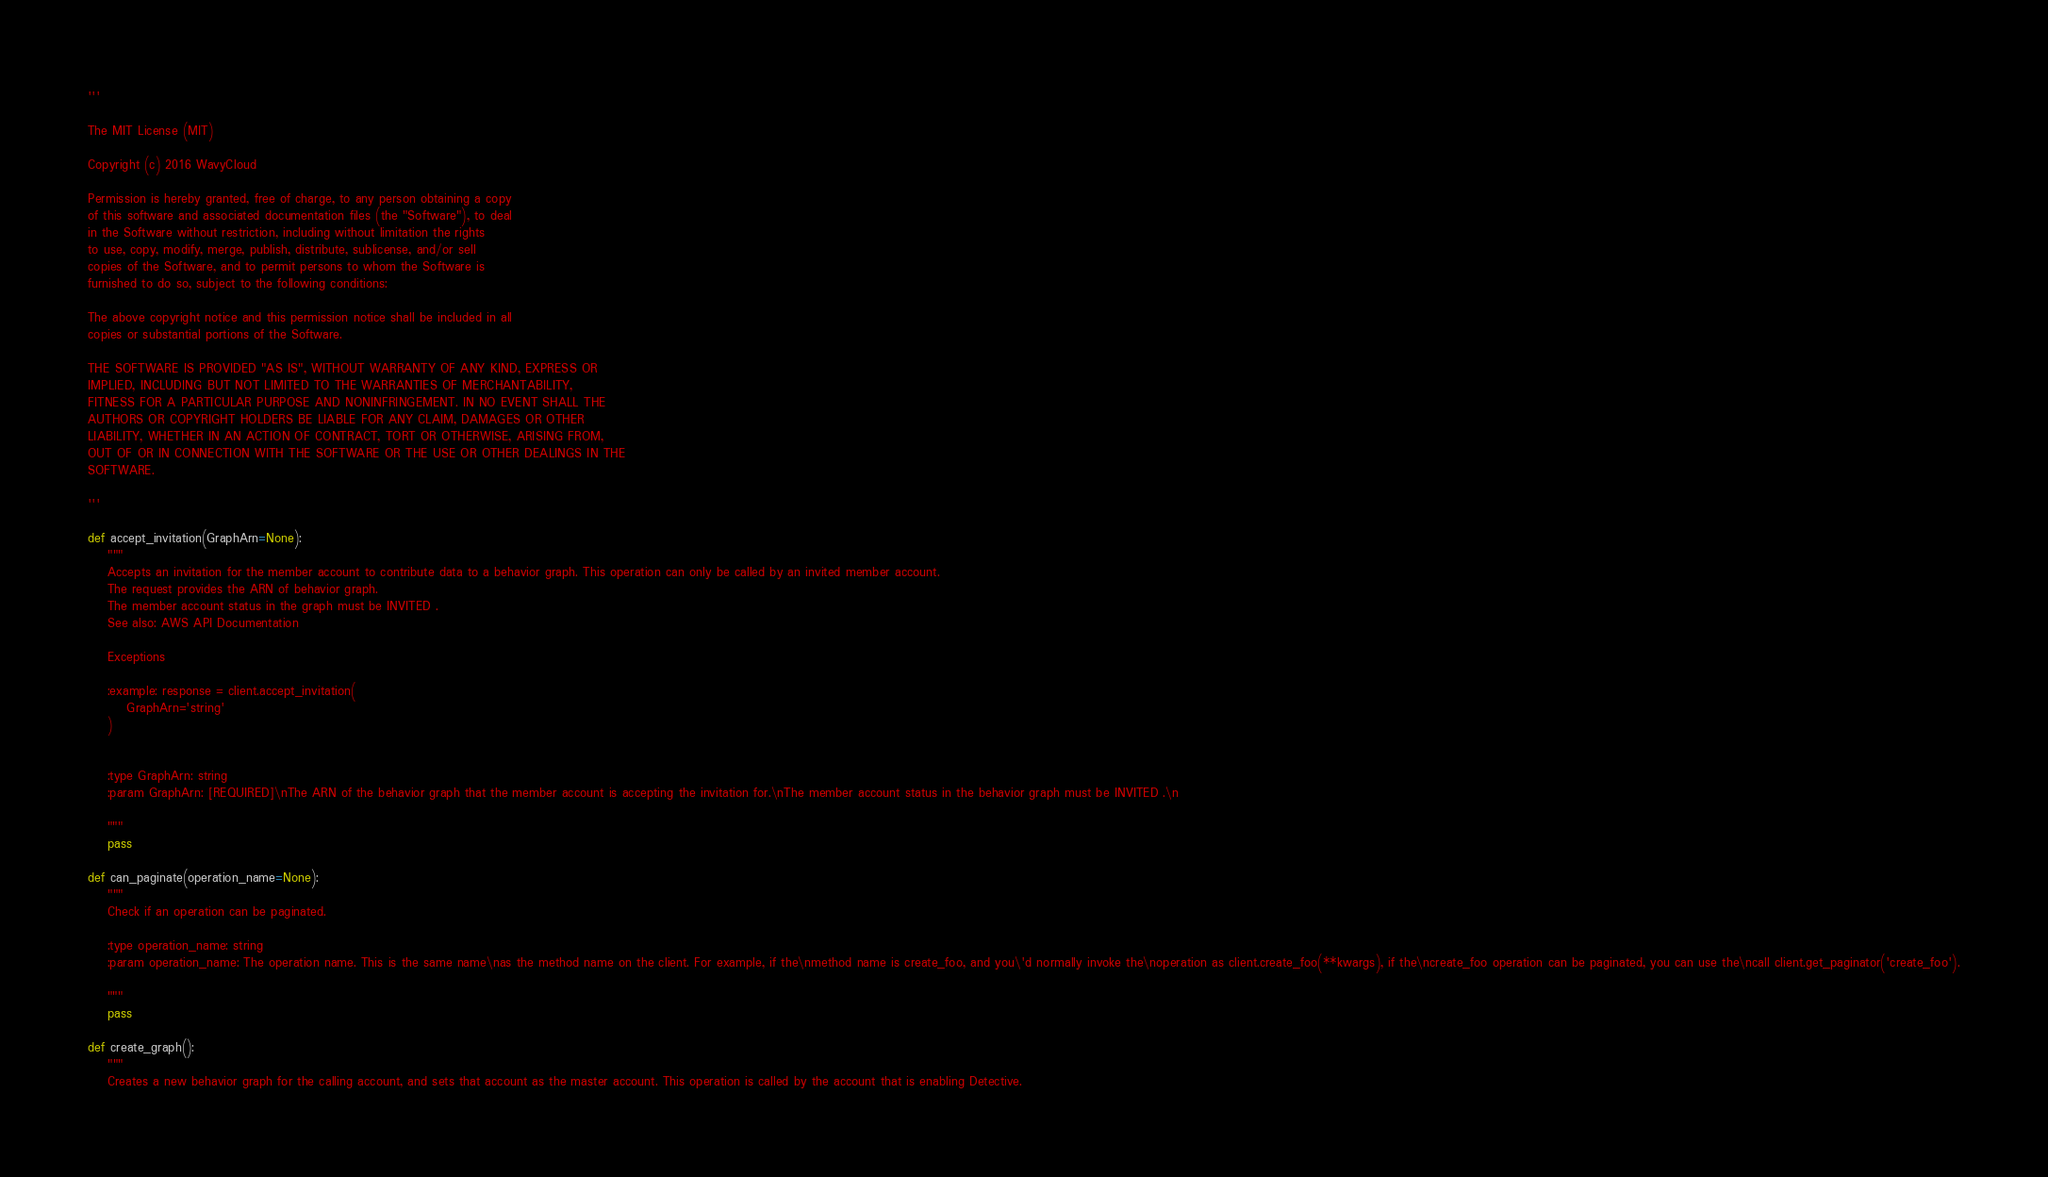<code> <loc_0><loc_0><loc_500><loc_500><_Python_>'''

The MIT License (MIT)

Copyright (c) 2016 WavyCloud

Permission is hereby granted, free of charge, to any person obtaining a copy
of this software and associated documentation files (the "Software"), to deal
in the Software without restriction, including without limitation the rights
to use, copy, modify, merge, publish, distribute, sublicense, and/or sell
copies of the Software, and to permit persons to whom the Software is
furnished to do so, subject to the following conditions:

The above copyright notice and this permission notice shall be included in all
copies or substantial portions of the Software.

THE SOFTWARE IS PROVIDED "AS IS", WITHOUT WARRANTY OF ANY KIND, EXPRESS OR
IMPLIED, INCLUDING BUT NOT LIMITED TO THE WARRANTIES OF MERCHANTABILITY,
FITNESS FOR A PARTICULAR PURPOSE AND NONINFRINGEMENT. IN NO EVENT SHALL THE
AUTHORS OR COPYRIGHT HOLDERS BE LIABLE FOR ANY CLAIM, DAMAGES OR OTHER
LIABILITY, WHETHER IN AN ACTION OF CONTRACT, TORT OR OTHERWISE, ARISING FROM,
OUT OF OR IN CONNECTION WITH THE SOFTWARE OR THE USE OR OTHER DEALINGS IN THE
SOFTWARE.

'''

def accept_invitation(GraphArn=None):
    """
    Accepts an invitation for the member account to contribute data to a behavior graph. This operation can only be called by an invited member account.
    The request provides the ARN of behavior graph.
    The member account status in the graph must be INVITED .
    See also: AWS API Documentation
    
    Exceptions
    
    :example: response = client.accept_invitation(
        GraphArn='string'
    )
    
    
    :type GraphArn: string
    :param GraphArn: [REQUIRED]\nThe ARN of the behavior graph that the member account is accepting the invitation for.\nThe member account status in the behavior graph must be INVITED .\n

    """
    pass

def can_paginate(operation_name=None):
    """
    Check if an operation can be paginated.
    
    :type operation_name: string
    :param operation_name: The operation name. This is the same name\nas the method name on the client. For example, if the\nmethod name is create_foo, and you\'d normally invoke the\noperation as client.create_foo(**kwargs), if the\ncreate_foo operation can be paginated, you can use the\ncall client.get_paginator('create_foo').

    """
    pass

def create_graph():
    """
    Creates a new behavior graph for the calling account, and sets that account as the master account. This operation is called by the account that is enabling Detective.</code> 